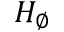Convert formula to latex. <formula><loc_0><loc_0><loc_500><loc_500>H _ { \varnothing }</formula> 